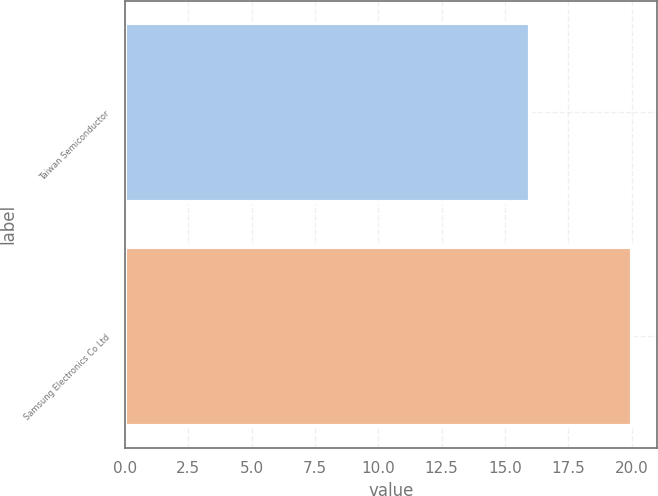Convert chart. <chart><loc_0><loc_0><loc_500><loc_500><bar_chart><fcel>Taiwan Semiconductor<fcel>Samsung Electronics Co Ltd<nl><fcel>16<fcel>20<nl></chart> 